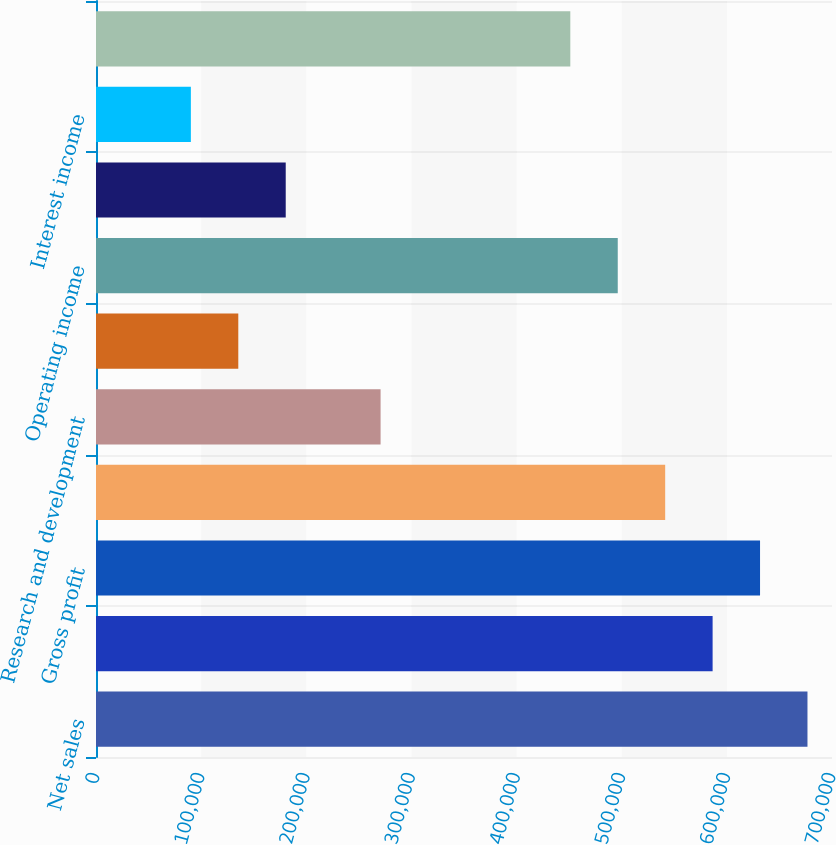<chart> <loc_0><loc_0><loc_500><loc_500><bar_chart><fcel>Net sales<fcel>Cost of sales<fcel>Gross profit<fcel>Selling and administrative<fcel>Research and development<fcel>Purchased intangibles<fcel>Operating income<fcel>Interest expense<fcel>Interest income<fcel>Income from operations before<nl><fcel>676672<fcel>586449<fcel>631561<fcel>541338<fcel>270669<fcel>135335<fcel>496226<fcel>180447<fcel>90223.8<fcel>451115<nl></chart> 